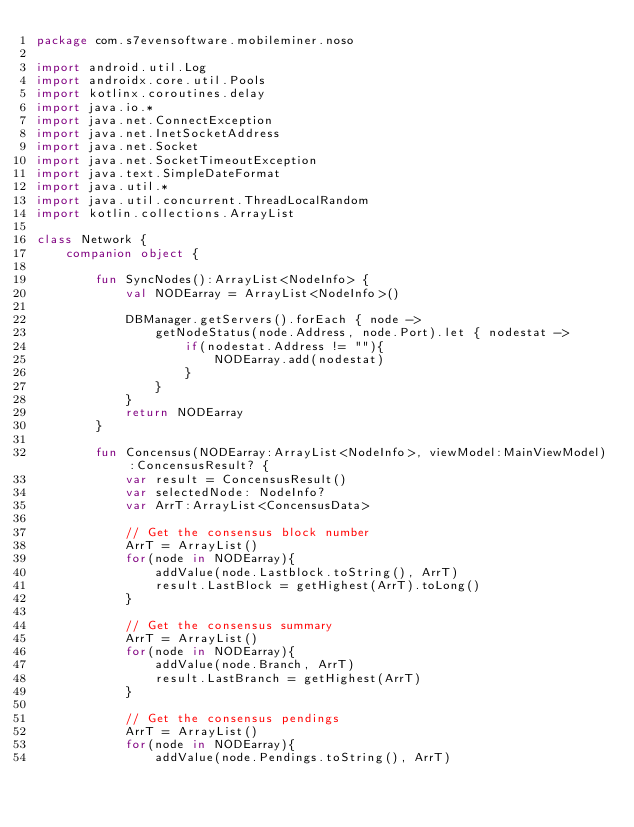<code> <loc_0><loc_0><loc_500><loc_500><_Kotlin_>package com.s7evensoftware.mobileminer.noso

import android.util.Log
import androidx.core.util.Pools
import kotlinx.coroutines.delay
import java.io.*
import java.net.ConnectException
import java.net.InetSocketAddress
import java.net.Socket
import java.net.SocketTimeoutException
import java.text.SimpleDateFormat
import java.util.*
import java.util.concurrent.ThreadLocalRandom
import kotlin.collections.ArrayList

class Network {
    companion object {

        fun SyncNodes():ArrayList<NodeInfo> {
            val NODEarray = ArrayList<NodeInfo>()

            DBManager.getServers().forEach { node ->
                getNodeStatus(node.Address, node.Port).let { nodestat ->
                    if(nodestat.Address != ""){
                        NODEarray.add(nodestat)
                    }
                }
            }
            return NODEarray
        }

        fun Concensus(NODEarray:ArrayList<NodeInfo>, viewModel:MainViewModel):ConcensusResult? {
            var result = ConcensusResult()
            var selectedNode: NodeInfo?
            var ArrT:ArrayList<ConcensusData>

            // Get the consensus block number
            ArrT = ArrayList()
            for(node in NODEarray){
                addValue(node.Lastblock.toString(), ArrT)
                result.LastBlock = getHighest(ArrT).toLong()
            }

            // Get the consensus summary
            ArrT = ArrayList()
            for(node in NODEarray){
                addValue(node.Branch, ArrT)
                result.LastBranch = getHighest(ArrT)
            }

            // Get the consensus pendings
            ArrT = ArrayList()
            for(node in NODEarray){
                addValue(node.Pendings.toString(), ArrT)</code> 